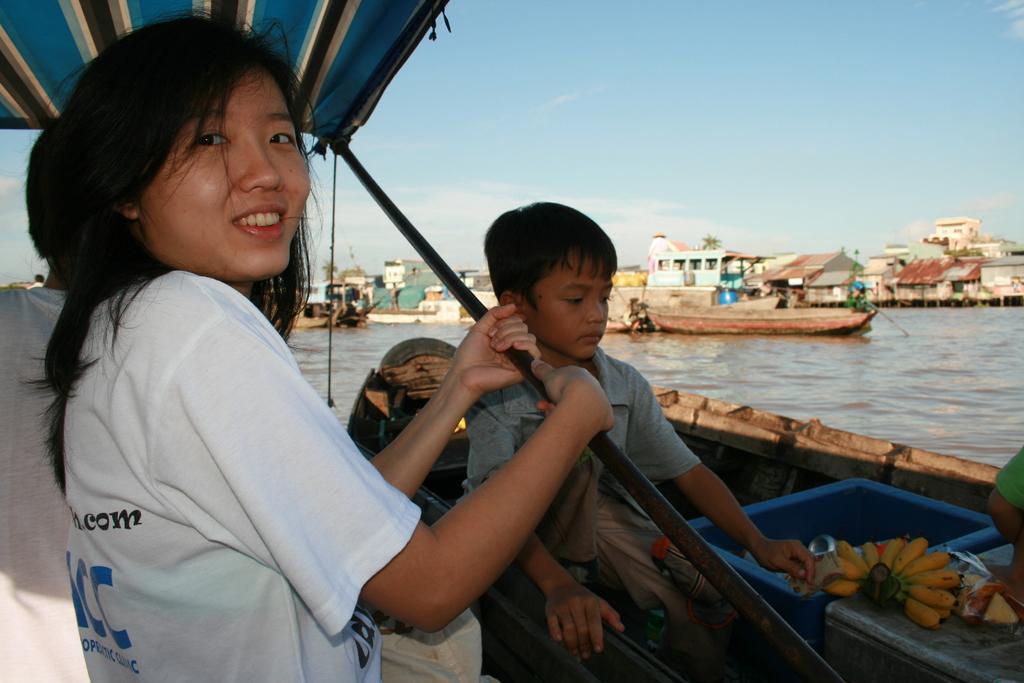Can you describe this image briefly? In this image we can see a lady and a boy in the boat and we can see sheds. There are boats on the water. In the background there is sky. 